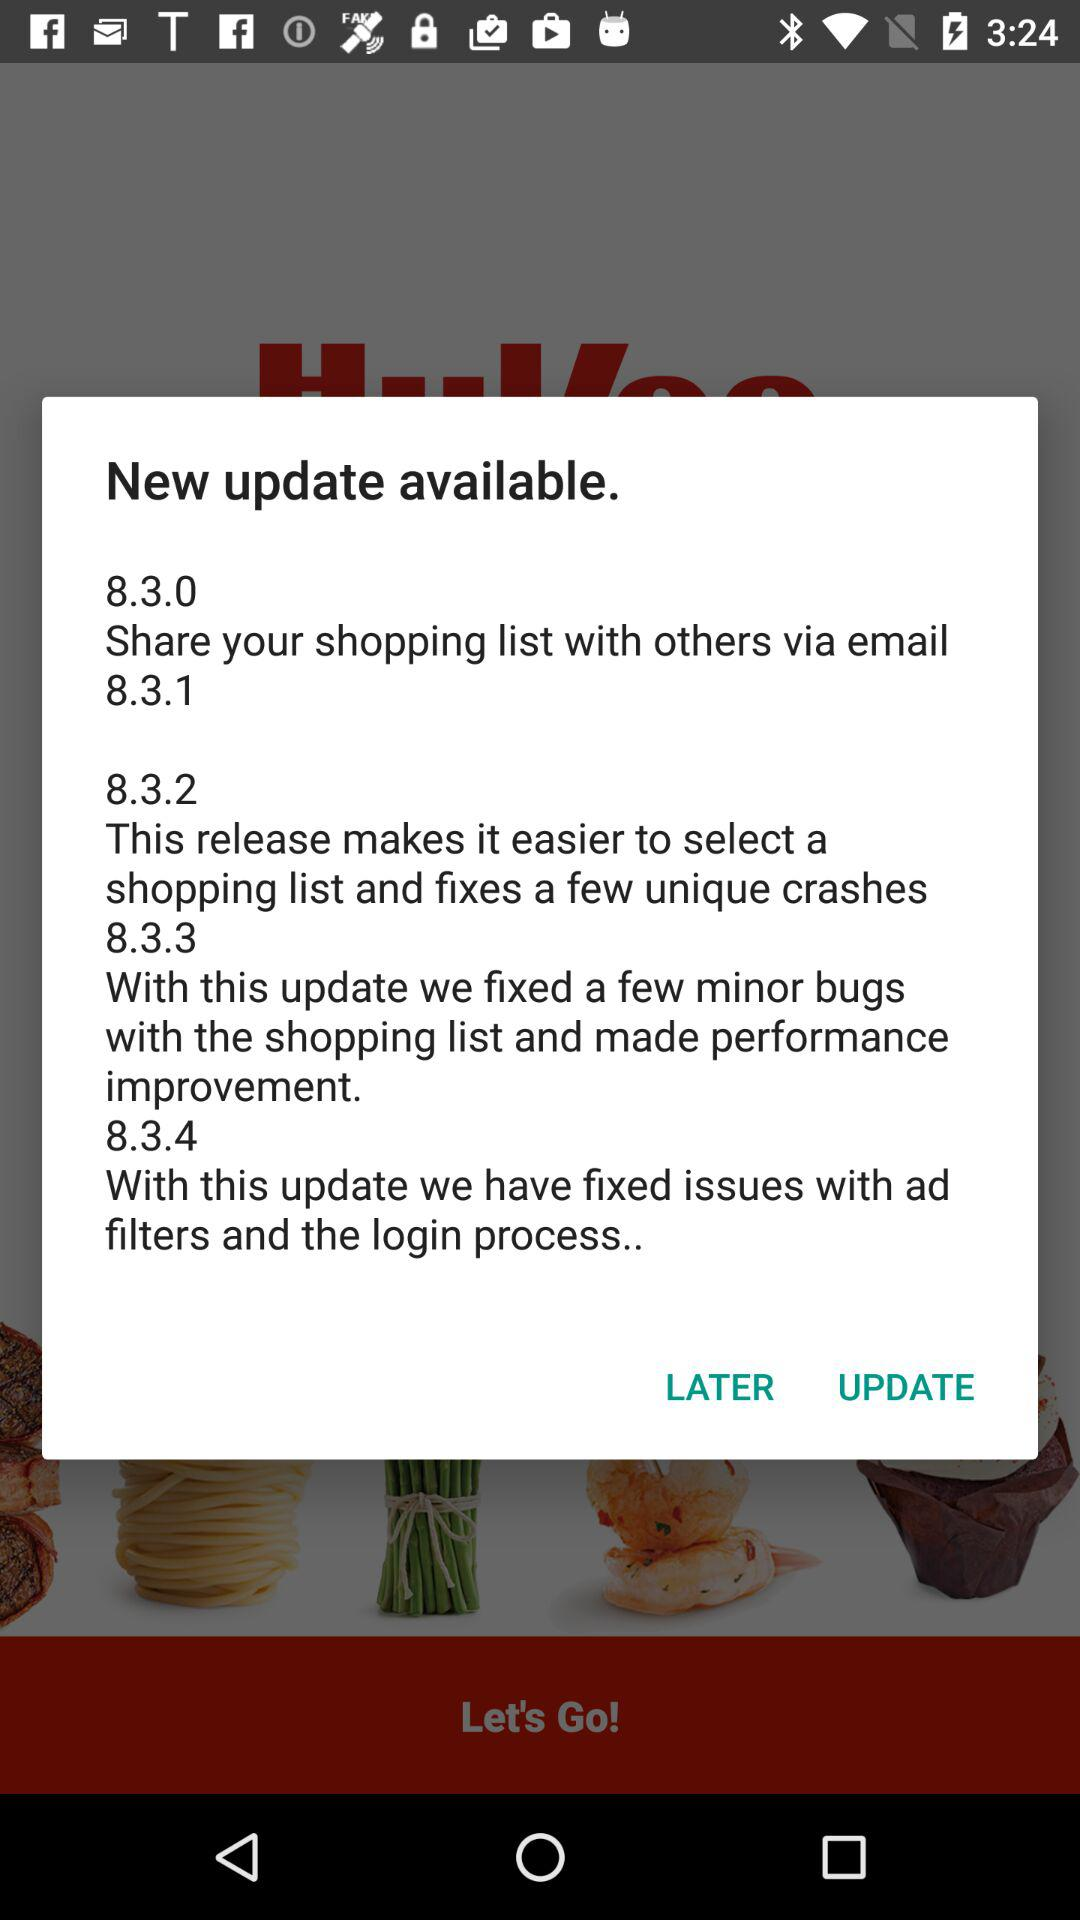What is the name of the application?
When the provided information is insufficient, respond with <no answer>. <no answer> 